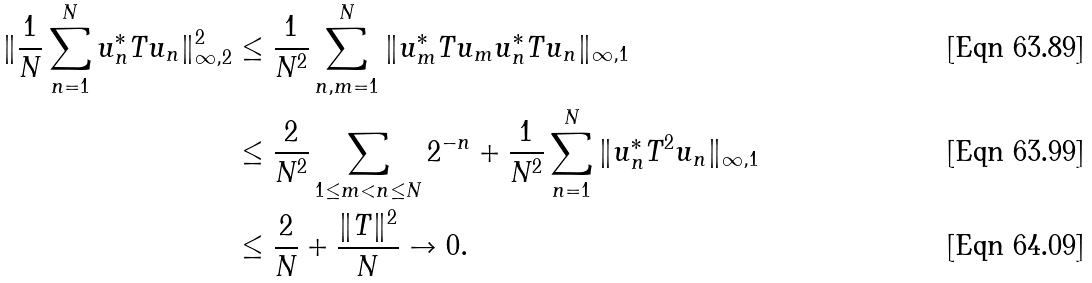<formula> <loc_0><loc_0><loc_500><loc_500>\| \frac { 1 } { N } \sum _ { n = 1 } ^ { N } u _ { n } ^ { * } T u _ { n } \| _ { \infty , 2 } ^ { 2 } & \leq \frac { 1 } { N ^ { 2 } } \sum _ { n , m = 1 } ^ { N } \| u _ { m } ^ { * } T u _ { m } u _ { n } ^ { * } T u _ { n } \| _ { \infty , 1 } \\ & \leq \frac { 2 } { N ^ { 2 } } \sum _ { 1 \leq m < n \leq N } 2 ^ { - n } + \frac { 1 } { N ^ { 2 } } \sum _ { n = 1 } ^ { N } \| u _ { n } ^ { * } T ^ { 2 } u _ { n } \| _ { \infty , 1 } \\ & \leq \frac { 2 } { N } + \frac { \| T \| ^ { 2 } } { N } \to 0 .</formula> 